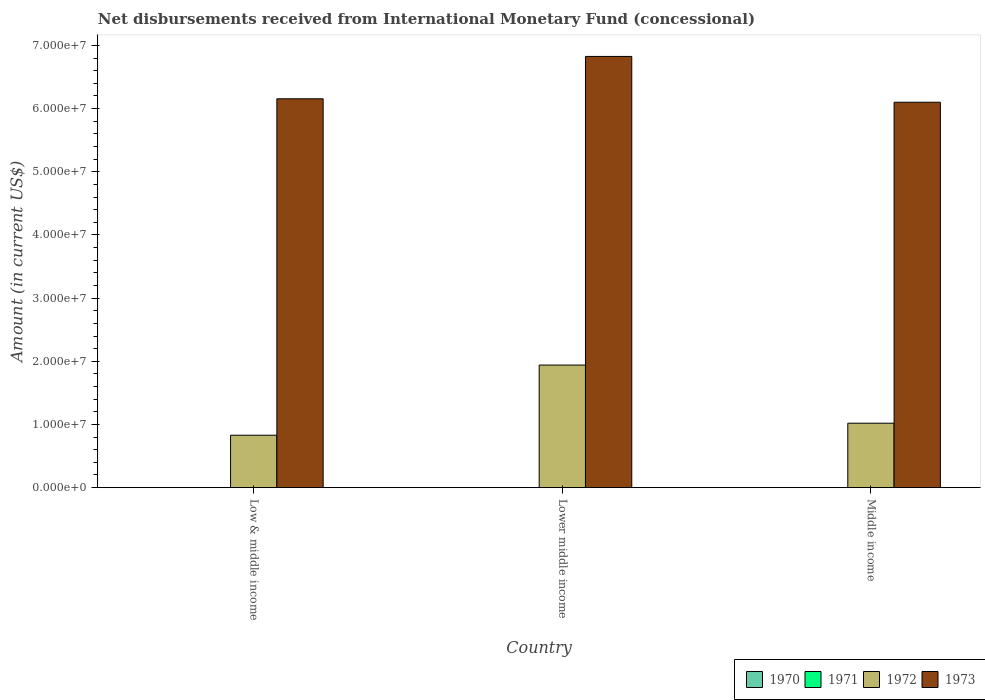How many different coloured bars are there?
Offer a terse response. 2. How many bars are there on the 2nd tick from the right?
Ensure brevity in your answer.  2. What is the amount of disbursements received from International Monetary Fund in 1973 in Middle income?
Offer a very short reply. 6.10e+07. Across all countries, what is the maximum amount of disbursements received from International Monetary Fund in 1973?
Your answer should be compact. 6.83e+07. Across all countries, what is the minimum amount of disbursements received from International Monetary Fund in 1970?
Provide a succinct answer. 0. In which country was the amount of disbursements received from International Monetary Fund in 1972 maximum?
Your answer should be very brief. Lower middle income. What is the total amount of disbursements received from International Monetary Fund in 1970 in the graph?
Ensure brevity in your answer.  0. What is the difference between the amount of disbursements received from International Monetary Fund in 1972 in Low & middle income and that in Middle income?
Give a very brief answer. -1.90e+06. What is the difference between the amount of disbursements received from International Monetary Fund in 1971 in Low & middle income and the amount of disbursements received from International Monetary Fund in 1970 in Middle income?
Offer a terse response. 0. What is the difference between the amount of disbursements received from International Monetary Fund of/in 1973 and amount of disbursements received from International Monetary Fund of/in 1972 in Low & middle income?
Make the answer very short. 5.33e+07. In how many countries, is the amount of disbursements received from International Monetary Fund in 1971 greater than 10000000 US$?
Offer a very short reply. 0. What is the ratio of the amount of disbursements received from International Monetary Fund in 1973 in Low & middle income to that in Lower middle income?
Keep it short and to the point. 0.9. Is the difference between the amount of disbursements received from International Monetary Fund in 1973 in Low & middle income and Middle income greater than the difference between the amount of disbursements received from International Monetary Fund in 1972 in Low & middle income and Middle income?
Offer a terse response. Yes. What is the difference between the highest and the second highest amount of disbursements received from International Monetary Fund in 1972?
Give a very brief answer. 9.21e+06. What is the difference between the highest and the lowest amount of disbursements received from International Monetary Fund in 1973?
Offer a terse response. 7.25e+06. Is the sum of the amount of disbursements received from International Monetary Fund in 1973 in Lower middle income and Middle income greater than the maximum amount of disbursements received from International Monetary Fund in 1972 across all countries?
Make the answer very short. Yes. Is it the case that in every country, the sum of the amount of disbursements received from International Monetary Fund in 1972 and amount of disbursements received from International Monetary Fund in 1970 is greater than the amount of disbursements received from International Monetary Fund in 1971?
Provide a succinct answer. Yes. How many bars are there?
Keep it short and to the point. 6. Are all the bars in the graph horizontal?
Offer a terse response. No. What is the difference between two consecutive major ticks on the Y-axis?
Make the answer very short. 1.00e+07. Are the values on the major ticks of Y-axis written in scientific E-notation?
Ensure brevity in your answer.  Yes. Where does the legend appear in the graph?
Keep it short and to the point. Bottom right. How many legend labels are there?
Provide a short and direct response. 4. How are the legend labels stacked?
Provide a short and direct response. Horizontal. What is the title of the graph?
Your answer should be compact. Net disbursements received from International Monetary Fund (concessional). What is the label or title of the X-axis?
Give a very brief answer. Country. What is the Amount (in current US$) of 1970 in Low & middle income?
Provide a short and direct response. 0. What is the Amount (in current US$) of 1971 in Low & middle income?
Offer a terse response. 0. What is the Amount (in current US$) of 1972 in Low & middle income?
Your answer should be compact. 8.30e+06. What is the Amount (in current US$) in 1973 in Low & middle income?
Make the answer very short. 6.16e+07. What is the Amount (in current US$) of 1972 in Lower middle income?
Offer a terse response. 1.94e+07. What is the Amount (in current US$) in 1973 in Lower middle income?
Your answer should be very brief. 6.83e+07. What is the Amount (in current US$) of 1970 in Middle income?
Offer a very short reply. 0. What is the Amount (in current US$) in 1972 in Middle income?
Give a very brief answer. 1.02e+07. What is the Amount (in current US$) of 1973 in Middle income?
Your answer should be very brief. 6.10e+07. Across all countries, what is the maximum Amount (in current US$) of 1972?
Your response must be concise. 1.94e+07. Across all countries, what is the maximum Amount (in current US$) of 1973?
Provide a succinct answer. 6.83e+07. Across all countries, what is the minimum Amount (in current US$) of 1972?
Provide a succinct answer. 8.30e+06. Across all countries, what is the minimum Amount (in current US$) of 1973?
Make the answer very short. 6.10e+07. What is the total Amount (in current US$) of 1972 in the graph?
Make the answer very short. 3.79e+07. What is the total Amount (in current US$) of 1973 in the graph?
Make the answer very short. 1.91e+08. What is the difference between the Amount (in current US$) in 1972 in Low & middle income and that in Lower middle income?
Provide a succinct answer. -1.11e+07. What is the difference between the Amount (in current US$) of 1973 in Low & middle income and that in Lower middle income?
Provide a short and direct response. -6.70e+06. What is the difference between the Amount (in current US$) of 1972 in Low & middle income and that in Middle income?
Your answer should be very brief. -1.90e+06. What is the difference between the Amount (in current US$) in 1973 in Low & middle income and that in Middle income?
Your answer should be very brief. 5.46e+05. What is the difference between the Amount (in current US$) of 1972 in Lower middle income and that in Middle income?
Your response must be concise. 9.21e+06. What is the difference between the Amount (in current US$) of 1973 in Lower middle income and that in Middle income?
Ensure brevity in your answer.  7.25e+06. What is the difference between the Amount (in current US$) in 1972 in Low & middle income and the Amount (in current US$) in 1973 in Lower middle income?
Provide a succinct answer. -6.00e+07. What is the difference between the Amount (in current US$) in 1972 in Low & middle income and the Amount (in current US$) in 1973 in Middle income?
Ensure brevity in your answer.  -5.27e+07. What is the difference between the Amount (in current US$) of 1972 in Lower middle income and the Amount (in current US$) of 1973 in Middle income?
Make the answer very short. -4.16e+07. What is the average Amount (in current US$) in 1972 per country?
Your answer should be very brief. 1.26e+07. What is the average Amount (in current US$) of 1973 per country?
Keep it short and to the point. 6.36e+07. What is the difference between the Amount (in current US$) in 1972 and Amount (in current US$) in 1973 in Low & middle income?
Provide a succinct answer. -5.33e+07. What is the difference between the Amount (in current US$) in 1972 and Amount (in current US$) in 1973 in Lower middle income?
Offer a very short reply. -4.89e+07. What is the difference between the Amount (in current US$) of 1972 and Amount (in current US$) of 1973 in Middle income?
Offer a terse response. -5.08e+07. What is the ratio of the Amount (in current US$) of 1972 in Low & middle income to that in Lower middle income?
Keep it short and to the point. 0.43. What is the ratio of the Amount (in current US$) of 1973 in Low & middle income to that in Lower middle income?
Ensure brevity in your answer.  0.9. What is the ratio of the Amount (in current US$) of 1972 in Low & middle income to that in Middle income?
Offer a very short reply. 0.81. What is the ratio of the Amount (in current US$) of 1972 in Lower middle income to that in Middle income?
Provide a succinct answer. 1.9. What is the ratio of the Amount (in current US$) of 1973 in Lower middle income to that in Middle income?
Give a very brief answer. 1.12. What is the difference between the highest and the second highest Amount (in current US$) of 1972?
Ensure brevity in your answer.  9.21e+06. What is the difference between the highest and the second highest Amount (in current US$) in 1973?
Offer a terse response. 6.70e+06. What is the difference between the highest and the lowest Amount (in current US$) of 1972?
Offer a very short reply. 1.11e+07. What is the difference between the highest and the lowest Amount (in current US$) of 1973?
Your answer should be very brief. 7.25e+06. 